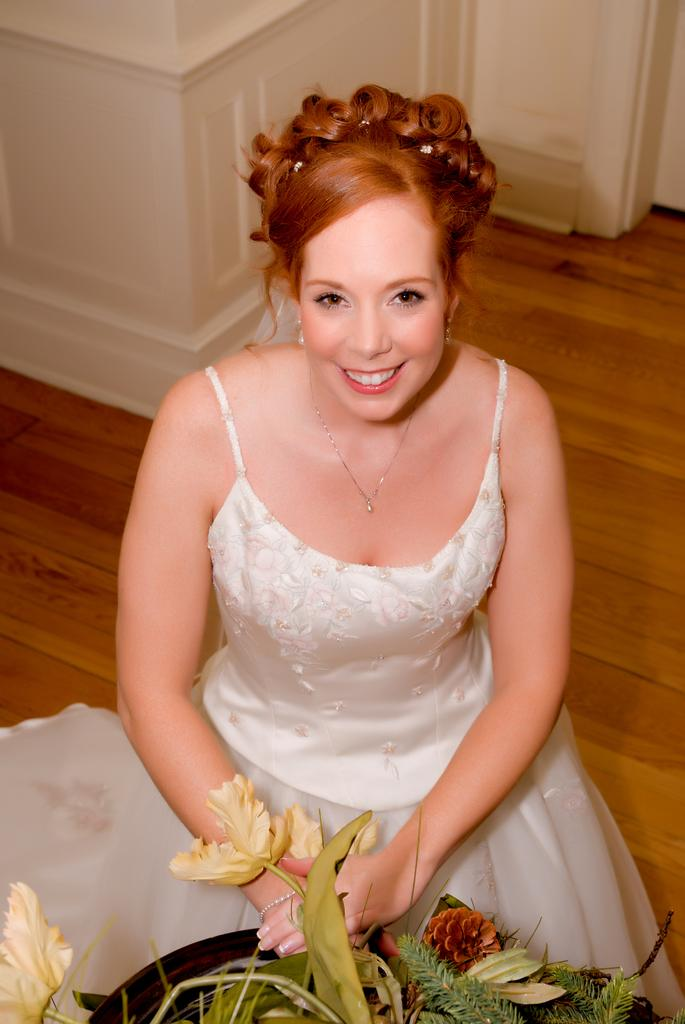What is the woman in the image doing? The woman is sitting on the floor in the image. What is in front of the woman? There is a plant with a pot in front of the woman. Where is the nearest station to the woman in the image? There is no information about a station in the image, so it cannot be determined. 